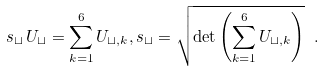<formula> <loc_0><loc_0><loc_500><loc_500>s _ { \sqcup } \, U _ { \sqcup } = \sum _ { k = 1 } ^ { 6 } U _ { \sqcup , k } , s _ { \sqcup } = \sqrt { \det \left ( \sum _ { k = 1 } ^ { 6 } U _ { \sqcup , k } \right ) } \ .</formula> 